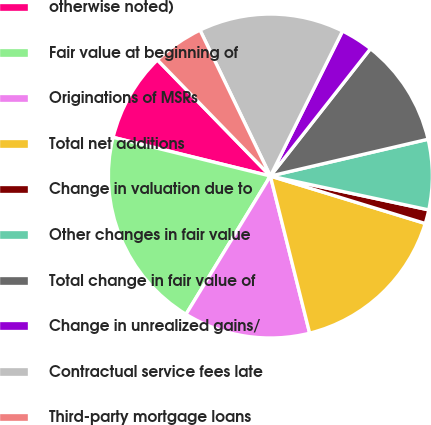Convert chart. <chart><loc_0><loc_0><loc_500><loc_500><pie_chart><fcel>otherwise noted)<fcel>Fair value at beginning of<fcel>Originations of MSRs<fcel>Total net additions<fcel>Change in valuation due to<fcel>Other changes in fair value<fcel>Total change in fair value of<fcel>Change in unrealized gains/<fcel>Contractual service fees late<fcel>Third-party mortgage loans<nl><fcel>8.88%<fcel>20.12%<fcel>12.62%<fcel>16.37%<fcel>1.38%<fcel>7.0%<fcel>10.75%<fcel>3.25%<fcel>14.5%<fcel>5.13%<nl></chart> 